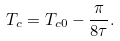Convert formula to latex. <formula><loc_0><loc_0><loc_500><loc_500>T _ { c } = T _ { c 0 } - \frac { \pi } { 8 \tau } .</formula> 